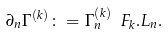<formula> <loc_0><loc_0><loc_500><loc_500>\partial _ { n } \Gamma ^ { ( k ) } \colon = \Gamma ^ { ( k ) } _ { n } \ F _ { k } . L _ { n } .</formula> 